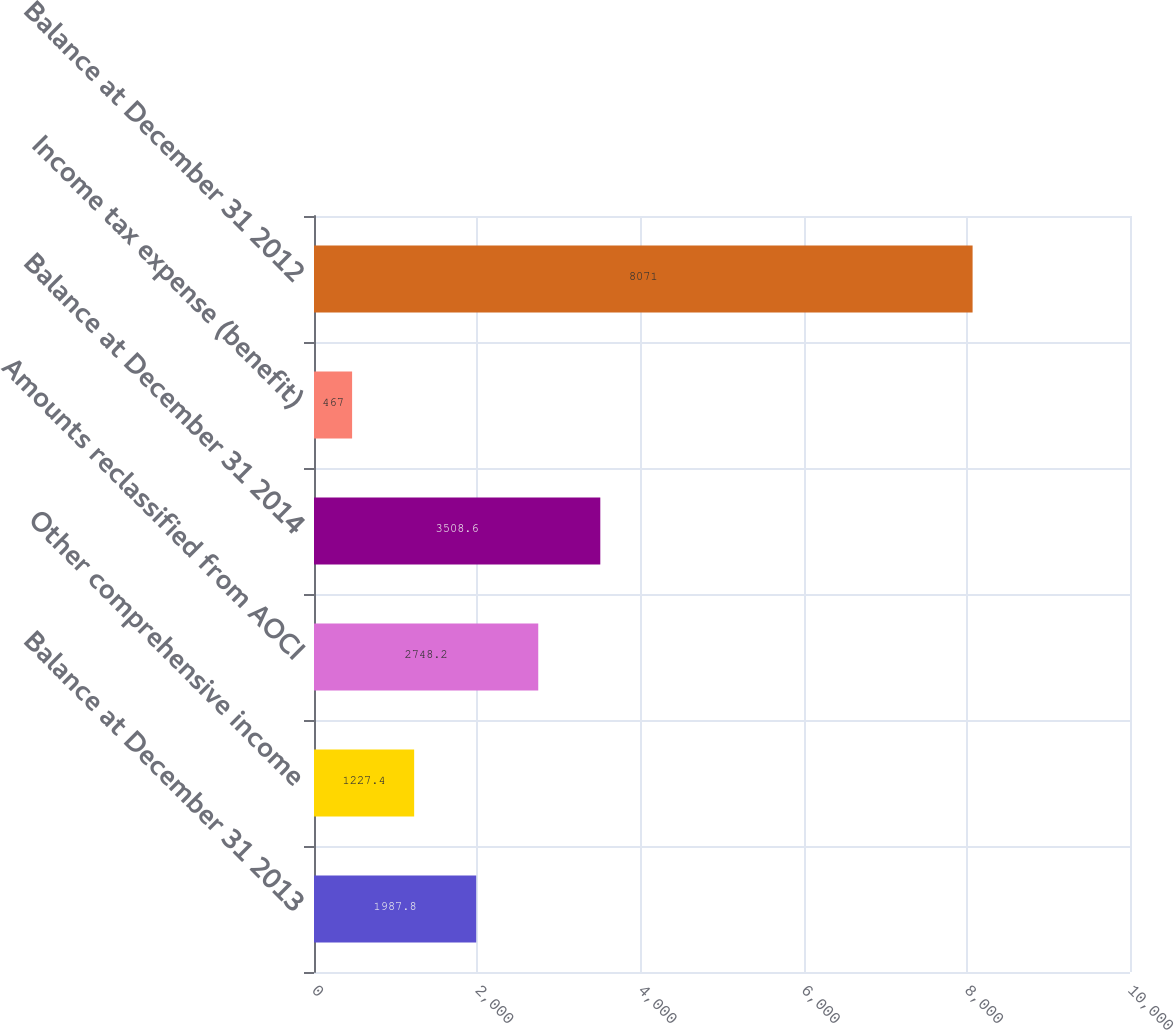Convert chart. <chart><loc_0><loc_0><loc_500><loc_500><bar_chart><fcel>Balance at December 31 2013<fcel>Other comprehensive income<fcel>Amounts reclassified from AOCI<fcel>Balance at December 31 2014<fcel>Income tax expense (benefit)<fcel>Balance at December 31 2012<nl><fcel>1987.8<fcel>1227.4<fcel>2748.2<fcel>3508.6<fcel>467<fcel>8071<nl></chart> 